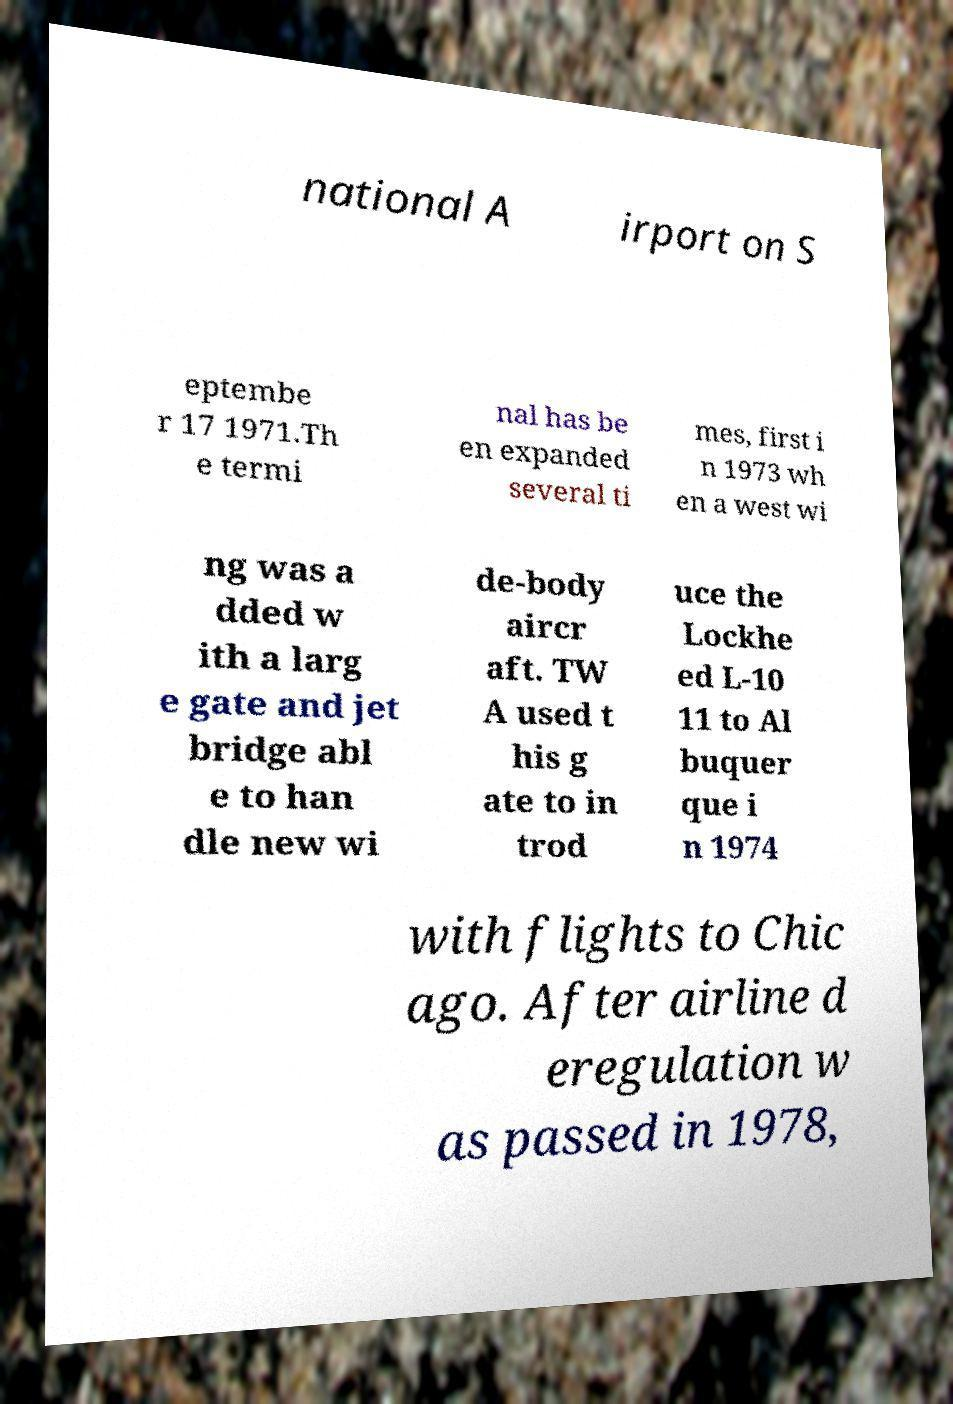Please read and relay the text visible in this image. What does it say? national A irport on S eptembe r 17 1971.Th e termi nal has be en expanded several ti mes, first i n 1973 wh en a west wi ng was a dded w ith a larg e gate and jet bridge abl e to han dle new wi de-body aircr aft. TW A used t his g ate to in trod uce the Lockhe ed L-10 11 to Al buquer que i n 1974 with flights to Chic ago. After airline d eregulation w as passed in 1978, 